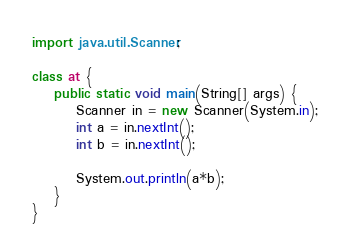<code> <loc_0><loc_0><loc_500><loc_500><_Java_>import java.util.Scanner;

class at {    
    public static void main(String[] args) { 
        Scanner in = new Scanner(System.in);
      	int a = in.nextInt();
        int b = in.nextInt();
        
        System.out.println(a*b);
    }
}</code> 